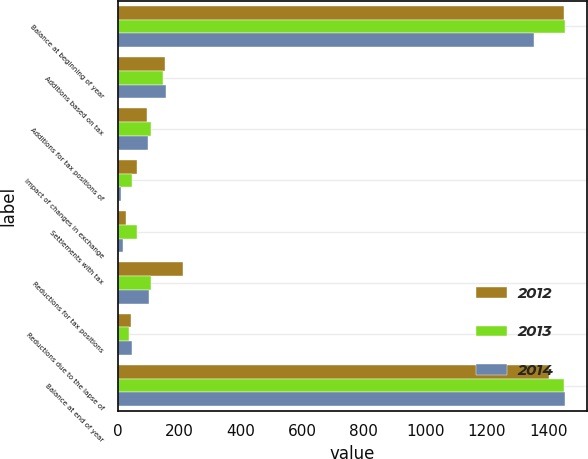Convert chart. <chart><loc_0><loc_0><loc_500><loc_500><stacked_bar_chart><ecel><fcel>Balance at beginning of year<fcel>Additions based on tax<fcel>Additions for tax positions of<fcel>Impact of changes in exchange<fcel>Settlements with tax<fcel>Reductions for tax positions<fcel>Reductions due to the lapse of<fcel>Balance at end of year<nl><fcel>2012<fcel>1452<fcel>154<fcel>96<fcel>62<fcel>27<fcel>212<fcel>42<fcel>1402<nl><fcel>2013<fcel>1453<fcel>146<fcel>109<fcel>47<fcel>64<fcel>109<fcel>36<fcel>1452<nl><fcel>2014<fcel>1353<fcel>156<fcel>98<fcel>12<fcel>17<fcel>103<fcel>46<fcel>1453<nl></chart> 